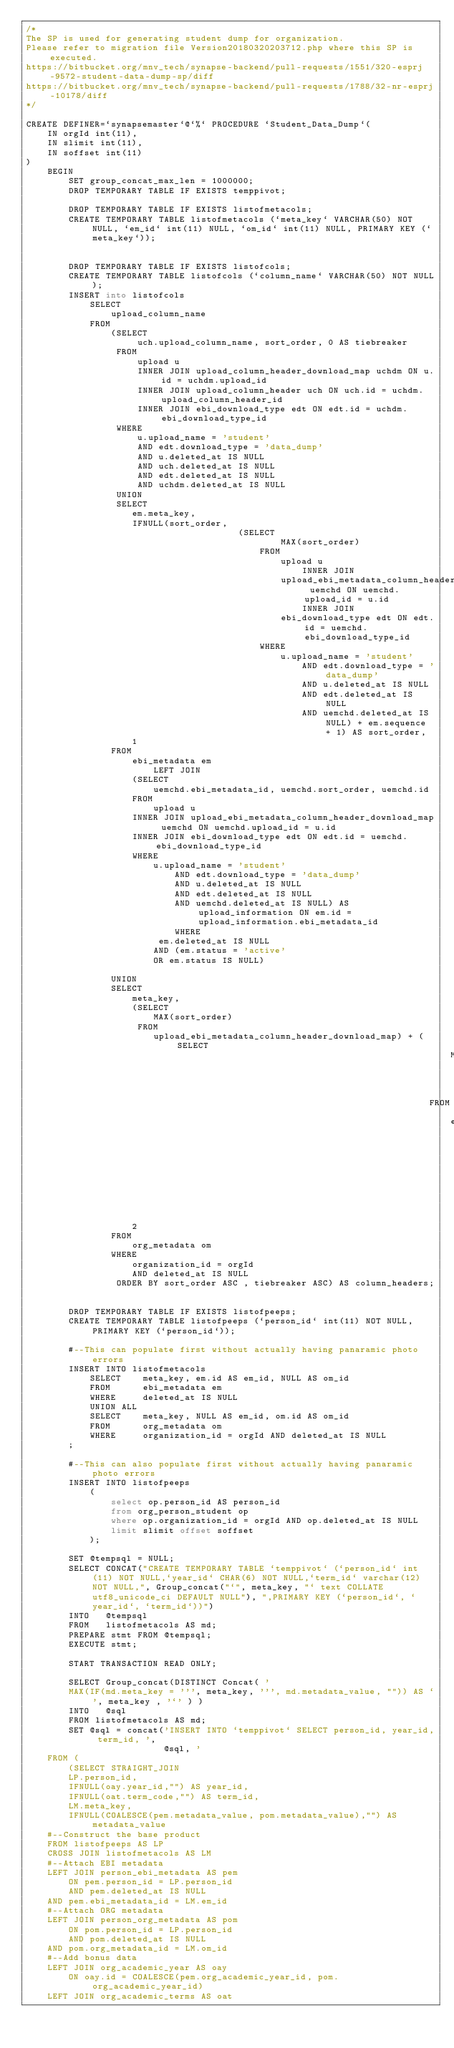Convert code to text. <code><loc_0><loc_0><loc_500><loc_500><_SQL_>/*
The SP is used for generating student dump for organization.
Please refer to migration file Version20180320203712.php where this SP is executed.
https://bitbucket.org/mnv_tech/synapse-backend/pull-requests/1551/320-esprj-9572-student-data-dump-sp/diff
https://bitbucket.org/mnv_tech/synapse-backend/pull-requests/1788/32-nr-esprj-10178/diff
*/

CREATE DEFINER=`synapsemaster`@`%` PROCEDURE `Student_Data_Dump`(
    IN orgId int(11),
    IN slimit int(11),
    IN soffset int(11)
)
    BEGIN
        SET group_concat_max_len = 1000000;
        DROP TEMPORARY TABLE IF EXISTS temppivot;

        DROP TEMPORARY TABLE IF EXISTS listofmetacols;
        CREATE TEMPORARY TABLE listofmetacols (`meta_key` VARCHAR(50) NOT NULL, `em_id` int(11) NULL, `om_id` int(11) NULL, PRIMARY KEY (`meta_key`));


        DROP TEMPORARY TABLE IF EXISTS listofcols;
        CREATE TEMPORARY TABLE listofcols (`column_name` VARCHAR(50) NOT NULL);
        INSERT into listofcols
            SELECT
                upload_column_name
            FROM
                (SELECT
                     uch.upload_column_name, sort_order, 0 AS tiebreaker
                 FROM
                     upload u
                     INNER JOIN upload_column_header_download_map uchdm ON u.id = uchdm.upload_id
                     INNER JOIN upload_column_header uch ON uch.id = uchdm.upload_column_header_id
                     INNER JOIN ebi_download_type edt ON edt.id = uchdm.ebi_download_type_id
                 WHERE
                     u.upload_name = 'student'
                     AND edt.download_type = 'data_dump'
                     AND u.deleted_at IS NULL
                     AND uch.deleted_at IS NULL
                     AND edt.deleted_at IS NULL
                     AND uchdm.deleted_at IS NULL
                 UNION
                 SELECT
                    em.meta_key,
                    IFNULL(sort_order,
                                        (SELECT
                                                MAX(sort_order)
                                            FROM
                                                upload u
                                                    INNER JOIN
                                                upload_ebi_metadata_column_header_download_map uemchd ON uemchd.upload_id = u.id
                                                    INNER JOIN
                                                ebi_download_type edt ON edt.id = uemchd.ebi_download_type_id
                                            WHERE
                                                u.upload_name = 'student'
                                                    AND edt.download_type = 'data_dump'
                                                    AND u.deleted_at IS NULL
                                                    AND edt.deleted_at IS NULL
                                                    AND uemchd.deleted_at IS NULL) + em.sequence + 1) AS sort_order,
                    1
                FROM
                    ebi_metadata em
                        LEFT JOIN
                    (SELECT
                        uemchd.ebi_metadata_id, uemchd.sort_order, uemchd.id
                    FROM
                        upload u
                    INNER JOIN upload_ebi_metadata_column_header_download_map uemchd ON uemchd.upload_id = u.id
                    INNER JOIN ebi_download_type edt ON edt.id = uemchd.ebi_download_type_id
                    WHERE
                        u.upload_name = 'student'
                            AND edt.download_type = 'data_dump'
                            AND u.deleted_at IS NULL
                            AND edt.deleted_at IS NULL
                            AND uemchd.deleted_at IS NULL) AS upload_information ON em.id = upload_information.ebi_metadata_id
                            WHERE
                         em.deleted_at IS NULL
                        AND (em.status = 'active'
                        OR em.status IS NULL)

                UNION
                SELECT
                    meta_key,
                    (SELECT
                        MAX(sort_order)
                     FROM
                        upload_ebi_metadata_column_header_download_map) + (SELECT
                                                                                MAX(sequence)
                                                                            FROM
                                                                                ebi_metadata) + sequence + 2,
                    2
                FROM
                    org_metadata om
                WHERE
                    organization_id = orgId
                    AND deleted_at IS NULL
                 ORDER BY sort_order ASC , tiebreaker ASC) AS column_headers;


        DROP TEMPORARY TABLE IF EXISTS listofpeeps;
        CREATE TEMPORARY TABLE listofpeeps (`person_id` int(11) NOT NULL,PRIMARY KEY (`person_id`));

        #--This can populate first without actually having panaramic photo errors
        INSERT INTO listofmetacols
            SELECT    meta_key, em.id AS em_id, NULL AS om_id
            FROM      ebi_metadata em
            WHERE     deleted_at IS NULL
            UNION ALL
            SELECT    meta_key, NULL AS em_id, om.id AS om_id
            FROM      org_metadata om
            WHERE     organization_id = orgId AND deleted_at IS NULL
        ;

        #--This can also populate first without actually having panaramic photo errors
        INSERT INTO listofpeeps
            (
                select op.person_id AS person_id
                from org_person_student op
                where op.organization_id = orgId AND op.deleted_at IS NULL
                limit slimit offset soffset
            );

        SET @tempsql = NULL;
        SELECT CONCAT("CREATE TEMPORARY TABLE `temppivot` (`person_id` int(11) NOT NULL,`year_id` CHAR(6) NOT NULL,`term_id` varchar(12) NOT NULL,", Group_concat("`", meta_key, "` text COLLATE utf8_unicode_ci DEFAULT NULL"), ",PRIMARY KEY (`person_id`, `year_id`, `term_id`))")
        INTO   @tempsql
        FROM   listofmetacols AS md;
        PREPARE stmt FROM @tempsql;
        EXECUTE stmt;

        START TRANSACTION READ ONLY;

        SELECT Group_concat(DISTINCT Concat( '
        MAX(IF(md.meta_key = ''', meta_key, ''', md.metadata_value, "")) AS `', meta_key , '`' ) )
        INTO   @sql
        FROM listofmetacols AS md;
        SET @sql = concat('INSERT INTO `temppivot` SELECT person_id, year_id, term_id, ',
                          @sql, '
    FROM (
        (SELECT STRAIGHT_JOIN
        LP.person_id,
        IFNULL(oay.year_id,"") AS year_id,
        IFNULL(oat.term_code,"") AS term_id,
        LM.meta_key,
        IFNULL(COALESCE(pem.metadata_value, pom.metadata_value),"") AS metadata_value
    #--Construct the base product
    FROM listofpeeps AS LP
    CROSS JOIN listofmetacols AS LM
    #--Attach EBI metadata
    LEFT JOIN person_ebi_metadata AS pem
        ON pem.person_id = LP.person_id
        AND pem.deleted_at IS NULL
    AND pem.ebi_metadata_id = LM.em_id
    #--Attach ORG metadata
    LEFT JOIN person_org_metadata AS pom
        ON pom.person_id = LP.person_id
        AND pom.deleted_at IS NULL
    AND pom.org_metadata_id = LM.om_id
    #--Add bonus data
    LEFT JOIN org_academic_year AS oay
        ON oay.id = COALESCE(pem.org_academic_year_id, pom.org_academic_year_id)
    LEFT JOIN org_academic_terms AS oat</code> 